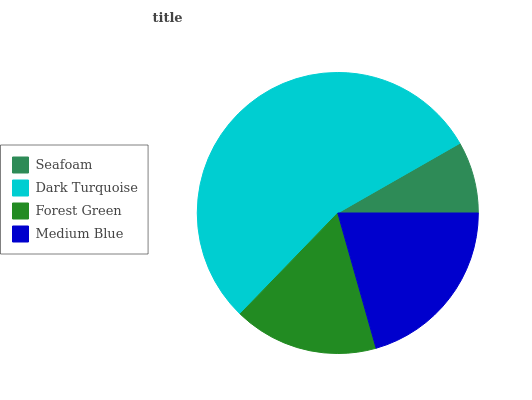Is Seafoam the minimum?
Answer yes or no. Yes. Is Dark Turquoise the maximum?
Answer yes or no. Yes. Is Forest Green the minimum?
Answer yes or no. No. Is Forest Green the maximum?
Answer yes or no. No. Is Dark Turquoise greater than Forest Green?
Answer yes or no. Yes. Is Forest Green less than Dark Turquoise?
Answer yes or no. Yes. Is Forest Green greater than Dark Turquoise?
Answer yes or no. No. Is Dark Turquoise less than Forest Green?
Answer yes or no. No. Is Medium Blue the high median?
Answer yes or no. Yes. Is Forest Green the low median?
Answer yes or no. Yes. Is Dark Turquoise the high median?
Answer yes or no. No. Is Seafoam the low median?
Answer yes or no. No. 